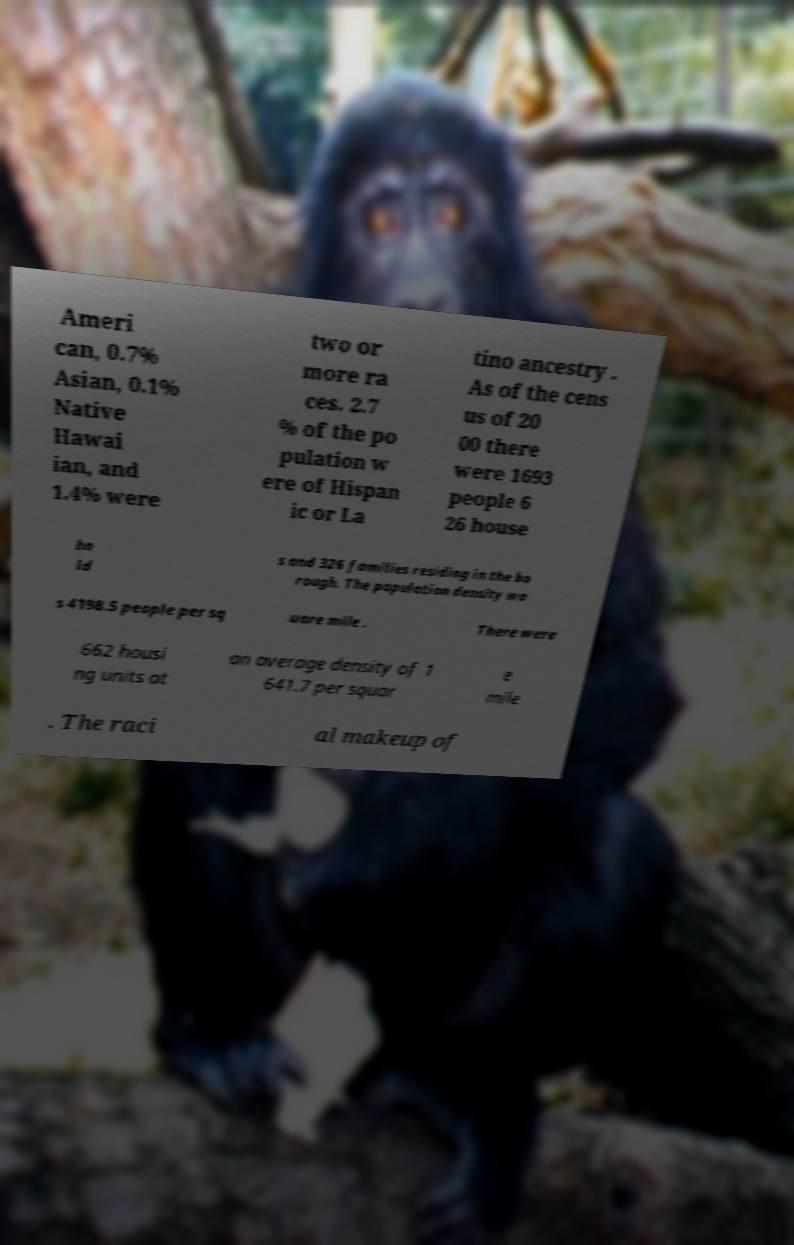Can you accurately transcribe the text from the provided image for me? Ameri can, 0.7% Asian, 0.1% Native Hawai ian, and 1.4% were two or more ra ces. 2.7 % of the po pulation w ere of Hispan ic or La tino ancestry . As of the cens us of 20 00 there were 1693 people 6 26 house ho ld s and 326 families residing in the bo rough. The population density wa s 4198.5 people per sq uare mile . There were 662 housi ng units at an average density of 1 641.7 per squar e mile . The raci al makeup of 